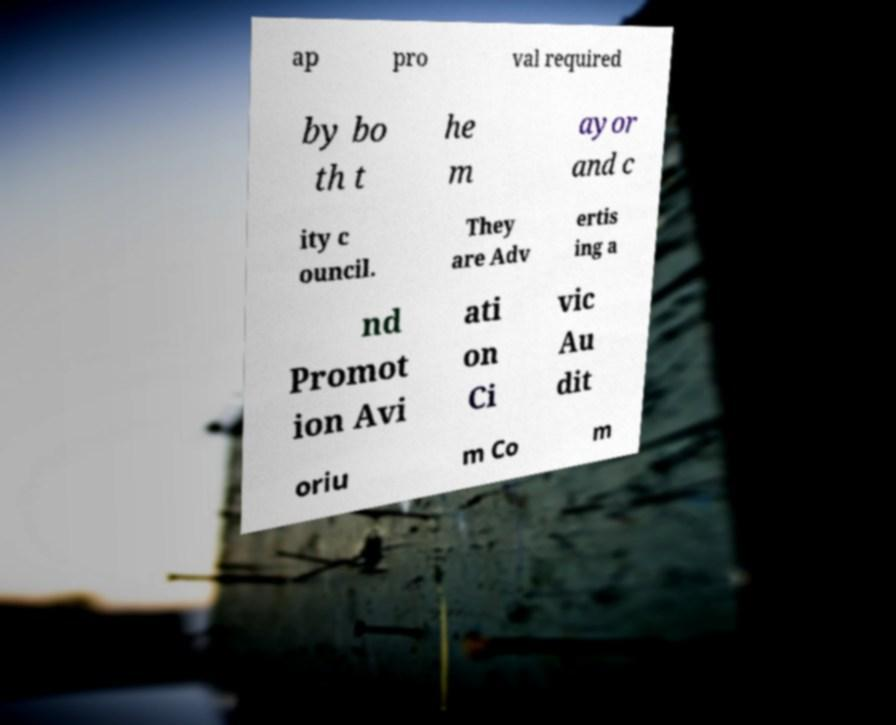Can you accurately transcribe the text from the provided image for me? ap pro val required by bo th t he m ayor and c ity c ouncil. They are Adv ertis ing a nd Promot ion Avi ati on Ci vic Au dit oriu m Co m 